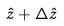<formula> <loc_0><loc_0><loc_500><loc_500>\hat { z } + \Delta \hat { z }</formula> 